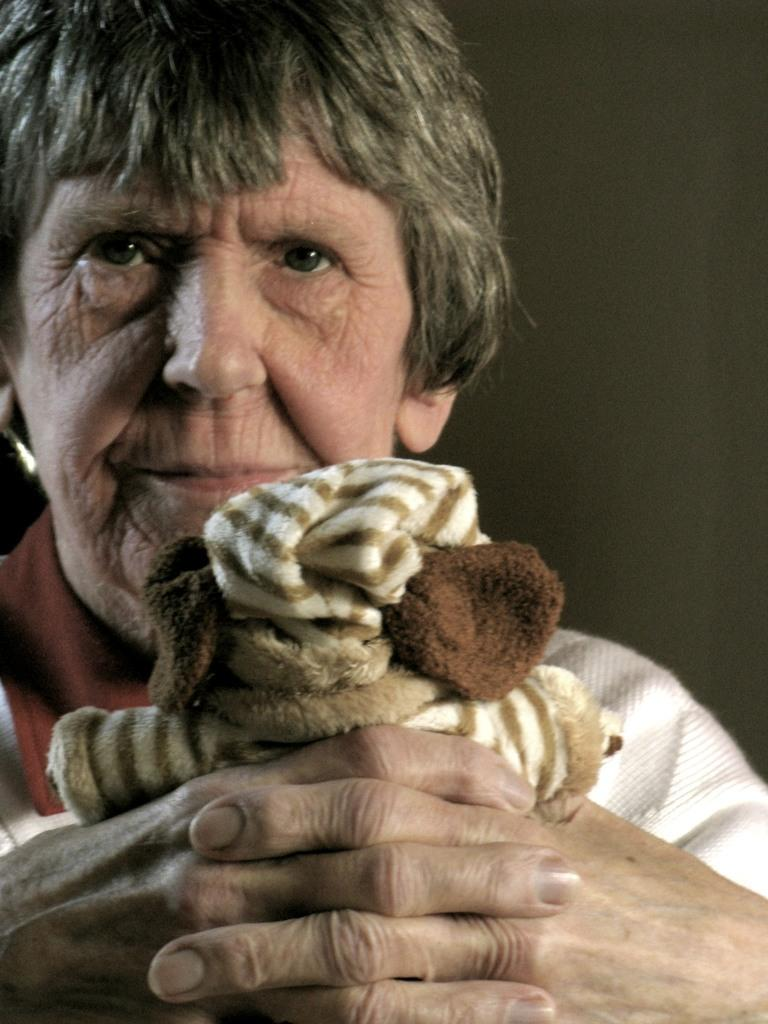Who or what is the main subject in the image? There is a person in the image. What is the person holding in the image? The person is holding a doll. Can you describe the background of the image? The background of the image is dark. What type of powder can be seen on the person's hands in the image? There is no powder visible on the person's hands in the image. 